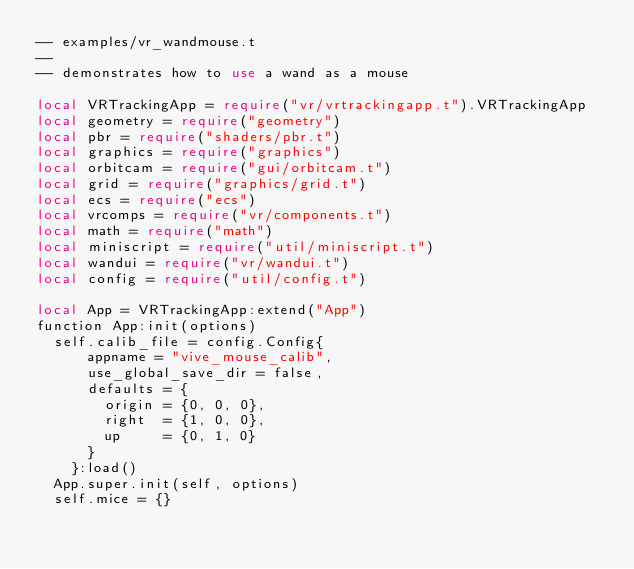Convert code to text. <code><loc_0><loc_0><loc_500><loc_500><_Perl_>-- examples/vr_wandmouse.t
--
-- demonstrates how to use a wand as a mouse

local VRTrackingApp = require("vr/vrtrackingapp.t").VRTrackingApp
local geometry = require("geometry")
local pbr = require("shaders/pbr.t")
local graphics = require("graphics")
local orbitcam = require("gui/orbitcam.t")
local grid = require("graphics/grid.t")
local ecs = require("ecs")
local vrcomps = require("vr/components.t")
local math = require("math")
local miniscript = require("util/miniscript.t")
local wandui = require("vr/wandui.t")
local config = require("util/config.t")

local App = VRTrackingApp:extend("App")
function App:init(options)
  self.calib_file = config.Config{
      appname = "vive_mouse_calib", 
      use_global_save_dir = false,
      defaults = {
        origin = {0, 0, 0},
        right  = {1, 0, 0},
        up     = {0, 1, 0}
      }
    }:load()
  App.super.init(self, options)
  self.mice = {}</code> 